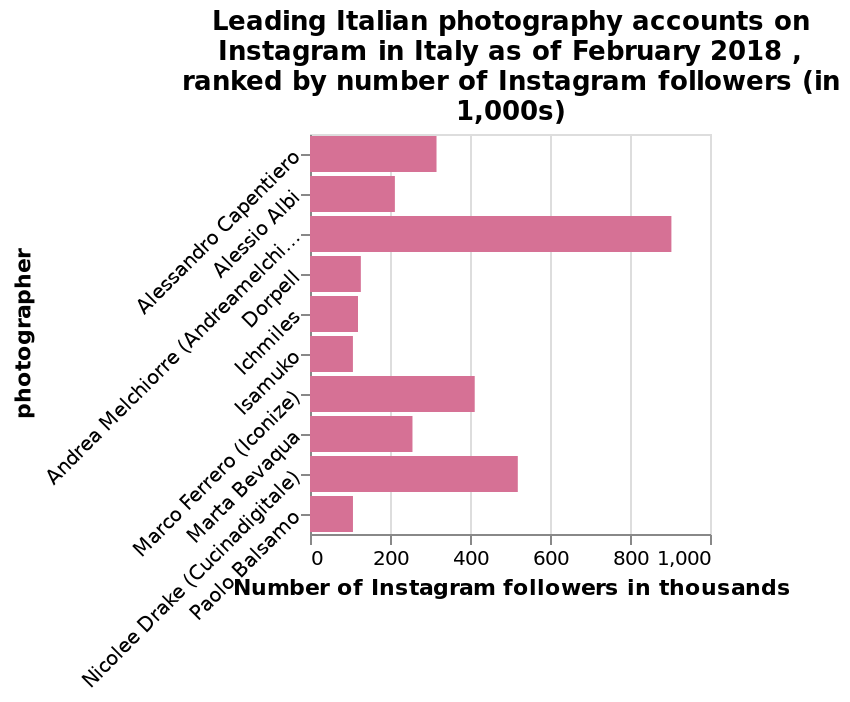<image>
please describe the details of the chart Here a is a bar plot named Leading Italian photography accounts on Instagram in Italy as of February 2018 , ranked by number of Instagram followers (in 1,000s). On the x-axis, Number of Instagram followers in thousands is plotted on a linear scale from 0 to 1,000. There is a categorical scale starting with Alessandro Capentiero and ending with Paolo Balsamo along the y-axis, marked photographer. What is plotted on the x-axis of the bar plot?  The x-axis of the bar plot represents the number of Instagram followers in thousands, plotted on a linear scale from 0 to 1,000. What is the unit of measurement for the number of Instagram followers on the x-axis? The unit of measurement for the number of Instagram followers on the x-axis is in thousands. What can be concluded about Andrea Melchiorre's Instagram account in 2018?  It had the leading photography account. What does the y-axis represent in the bar plot? The y-axis represents a categorical scale of Italian photographers, starting with Alessandro Capentiero and ending with Paolo Balsamo. 